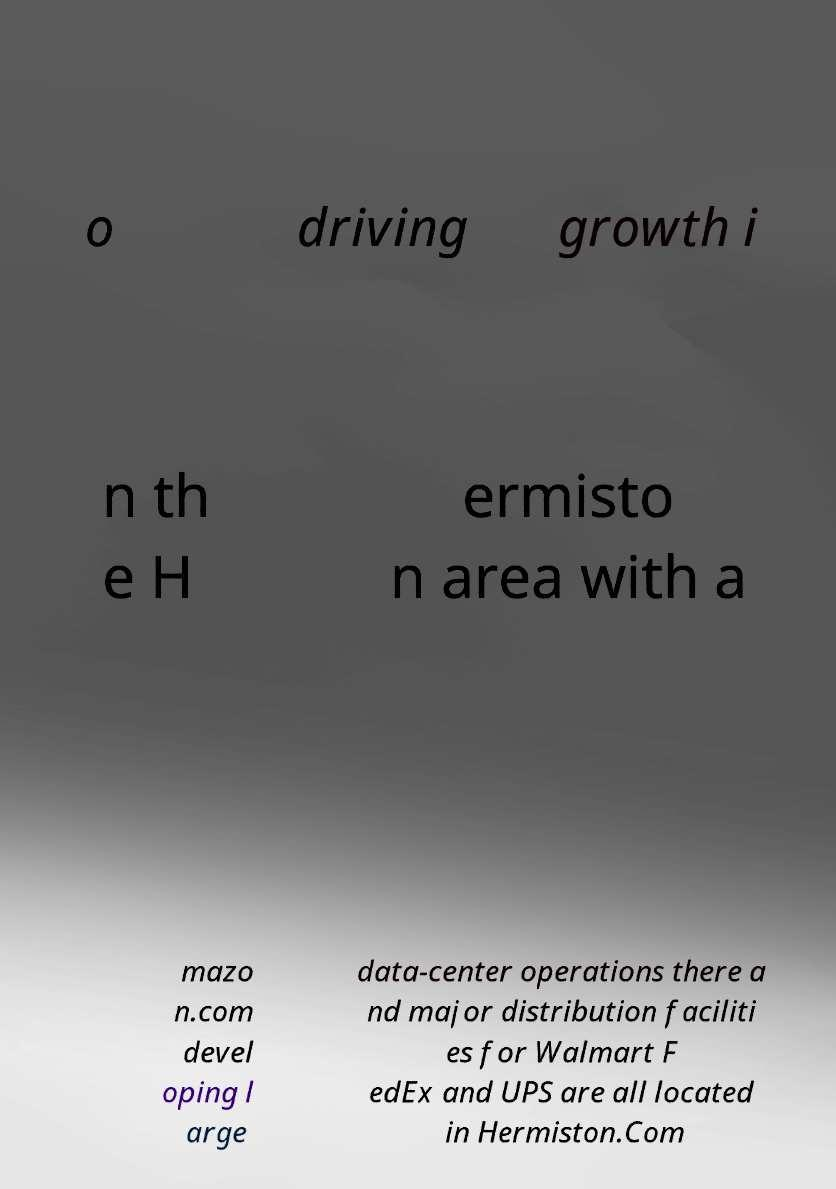Could you assist in decoding the text presented in this image and type it out clearly? o driving growth i n th e H ermisto n area with a mazo n.com devel oping l arge data-center operations there a nd major distribution faciliti es for Walmart F edEx and UPS are all located in Hermiston.Com 